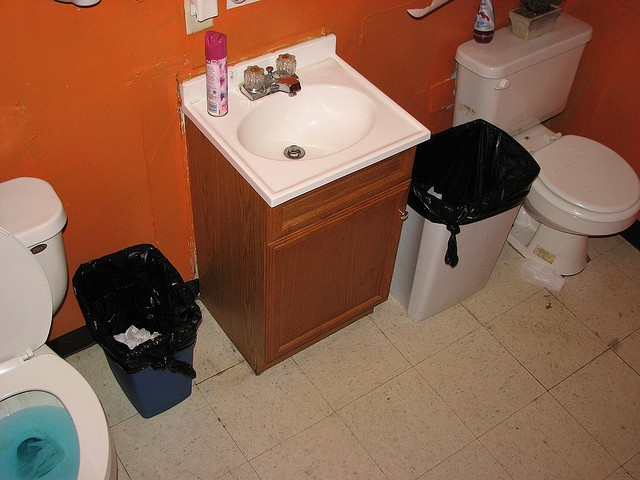Describe the objects in this image and their specific colors. I can see toilet in brown, gray, and darkgray tones, sink in brown, lightgray, tan, and darkgray tones, and toilet in brown, darkgray, lightgray, and teal tones in this image. 